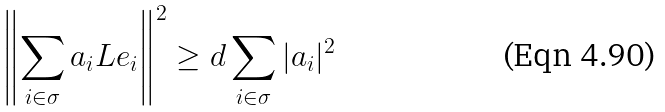<formula> <loc_0><loc_0><loc_500><loc_500>\left \| \sum _ { i \in \sigma } a _ { i } L e _ { i } \right \| ^ { 2 } \geq d \sum _ { i \in \sigma } | a _ { i } | ^ { 2 }</formula> 